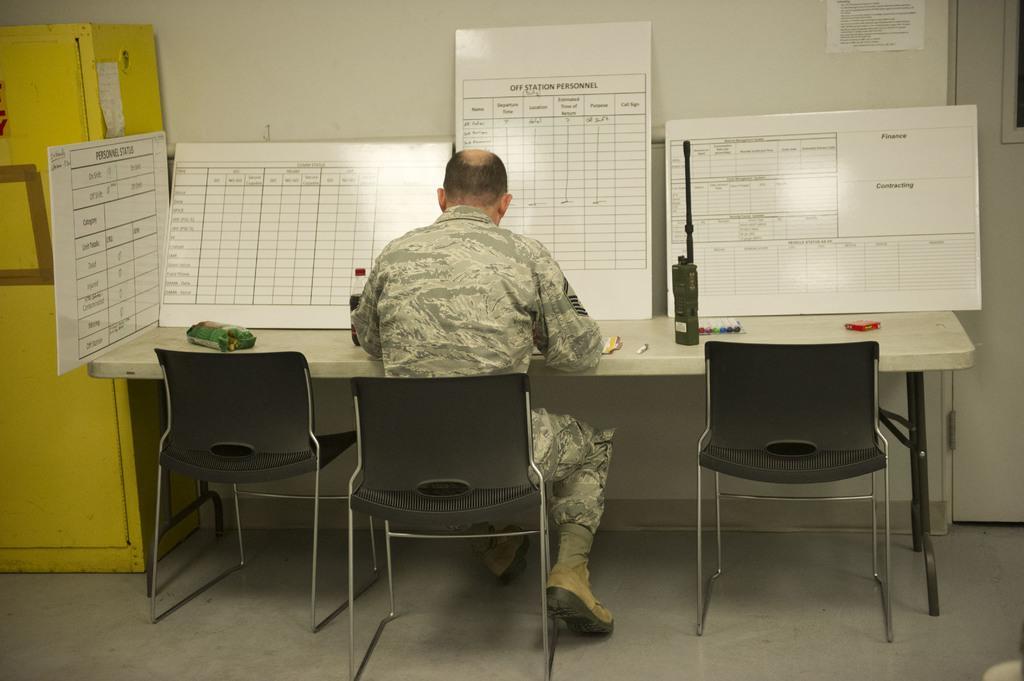Could you give a brief overview of what you see in this image? This is a picture of a man sitting on a chair, in front of the man there is a table on the table there is a bottle, walkie talkie and packet on the table there are the white color boards. Background of this boards is a wall which is in white color. On the left side of the man there is a shelf which is in yellow color. 